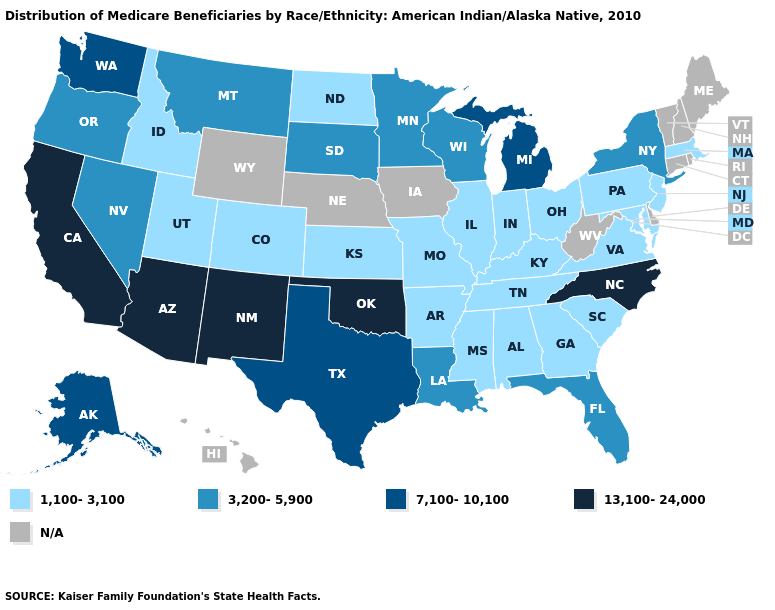Name the states that have a value in the range 1,100-3,100?
Answer briefly. Alabama, Arkansas, Colorado, Georgia, Idaho, Illinois, Indiana, Kansas, Kentucky, Maryland, Massachusetts, Mississippi, Missouri, New Jersey, North Dakota, Ohio, Pennsylvania, South Carolina, Tennessee, Utah, Virginia. Which states have the lowest value in the South?
Write a very short answer. Alabama, Arkansas, Georgia, Kentucky, Maryland, Mississippi, South Carolina, Tennessee, Virginia. What is the lowest value in the USA?
Write a very short answer. 1,100-3,100. What is the value of Pennsylvania?
Write a very short answer. 1,100-3,100. Which states have the highest value in the USA?
Be succinct. Arizona, California, New Mexico, North Carolina, Oklahoma. What is the highest value in the USA?
Quick response, please. 13,100-24,000. Does Utah have the lowest value in the West?
Answer briefly. Yes. What is the highest value in the USA?
Concise answer only. 13,100-24,000. Name the states that have a value in the range N/A?
Answer briefly. Connecticut, Delaware, Hawaii, Iowa, Maine, Nebraska, New Hampshire, Rhode Island, Vermont, West Virginia, Wyoming. Is the legend a continuous bar?
Be succinct. No. What is the highest value in the Northeast ?
Be succinct. 3,200-5,900. Among the states that border New York , which have the lowest value?
Quick response, please. Massachusetts, New Jersey, Pennsylvania. Name the states that have a value in the range 13,100-24,000?
Short answer required. Arizona, California, New Mexico, North Carolina, Oklahoma. Among the states that border Ohio , which have the lowest value?
Short answer required. Indiana, Kentucky, Pennsylvania. 